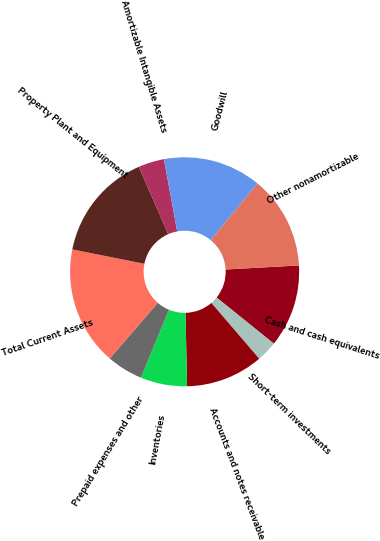Convert chart to OTSL. <chart><loc_0><loc_0><loc_500><loc_500><pie_chart><fcel>Cash and cash equivalents<fcel>Short-term investments<fcel>Accounts and notes receivable<fcel>Inventories<fcel>Prepaid expenses and other<fcel>Total Current Assets<fcel>Property Plant and Equipment<fcel>Amortizable Intangible Assets<fcel>Goodwill<fcel>Other nonamortizable<nl><fcel>11.68%<fcel>2.92%<fcel>10.95%<fcel>6.57%<fcel>5.11%<fcel>16.79%<fcel>15.33%<fcel>3.65%<fcel>13.87%<fcel>13.14%<nl></chart> 